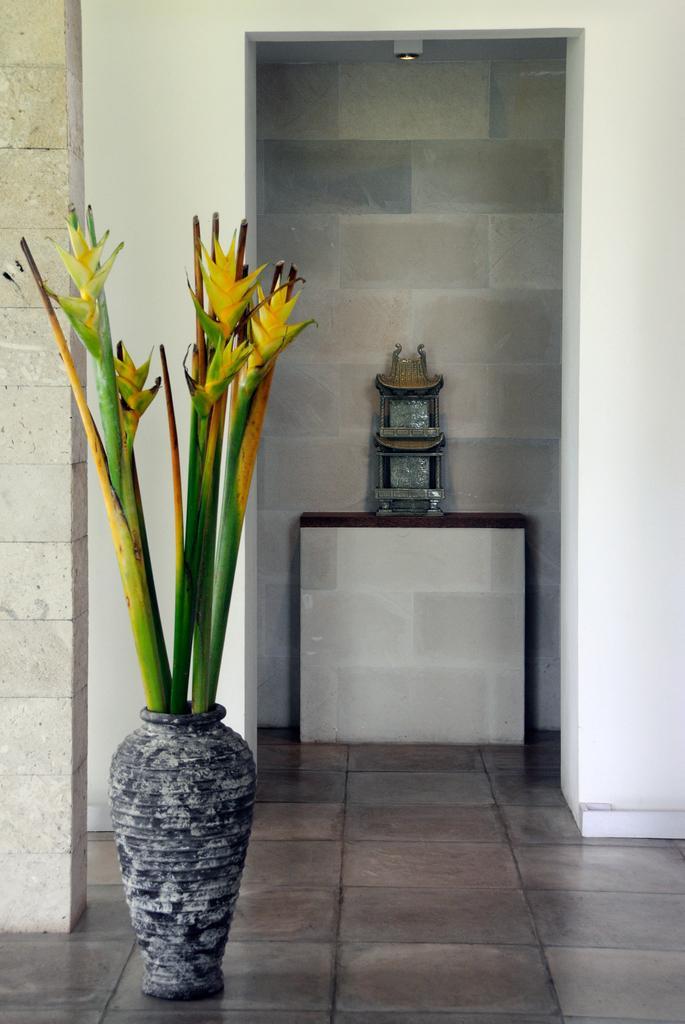How would you summarize this image in a sentence or two? In this picture I can see an object on the pedestal. I can see a flower vase, and in the background there are walls. 